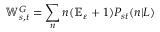Convert formula to latex. <formula><loc_0><loc_0><loc_500><loc_500>\mathbb { W } _ { s , t } ^ { G } = \sum _ { n } n ( \mathbb { E } _ { \varepsilon } + 1 ) P _ { s t } ( n | L )</formula> 